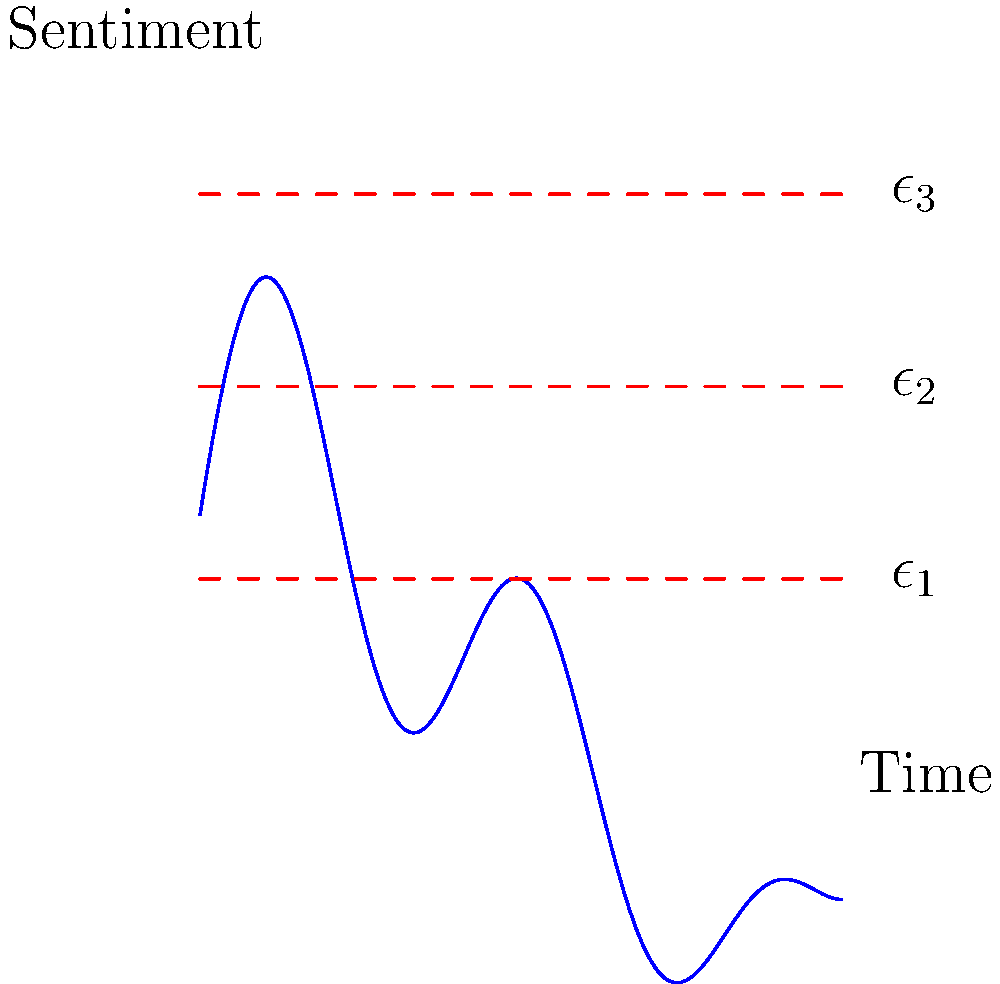Consider the time series of sentiment analysis shown in the figure, derived from historical documents. If we apply persistent homology to this data, what is the most likely dimension of the longest persisting topological feature in the resulting persistence diagram? To determine the most likely dimension of the longest persisting topological feature, let's analyze the time series step-by-step:

1. The given curve represents sentiment analysis over time, where peaks and troughs indicate changes in sentiment.

2. In persistent homology, we consider the sublevel sets of the function at different filtration levels ($\epsilon_1$, $\epsilon_2$, $\epsilon_3$).

3. As we increase the filtration level:
   - At $\epsilon_1$: We see multiple disconnected components (0-dimensional features).
   - At $\epsilon_2$: Some components merge, but we still have multiple components.
   - At $\epsilon_3$: Almost all components are connected, forming a single component.

4. The 0-dimensional features (connected components) persist throughout the filtration process, from the lowest to the highest level.

5. We don't observe any clear loops or voids forming in this 1-dimensional time series, which would correspond to higher-dimensional features.

6. Therefore, the 0-dimensional features (connected components) are likely to have the longest persistence in the resulting persistence diagram.
Answer: 0 